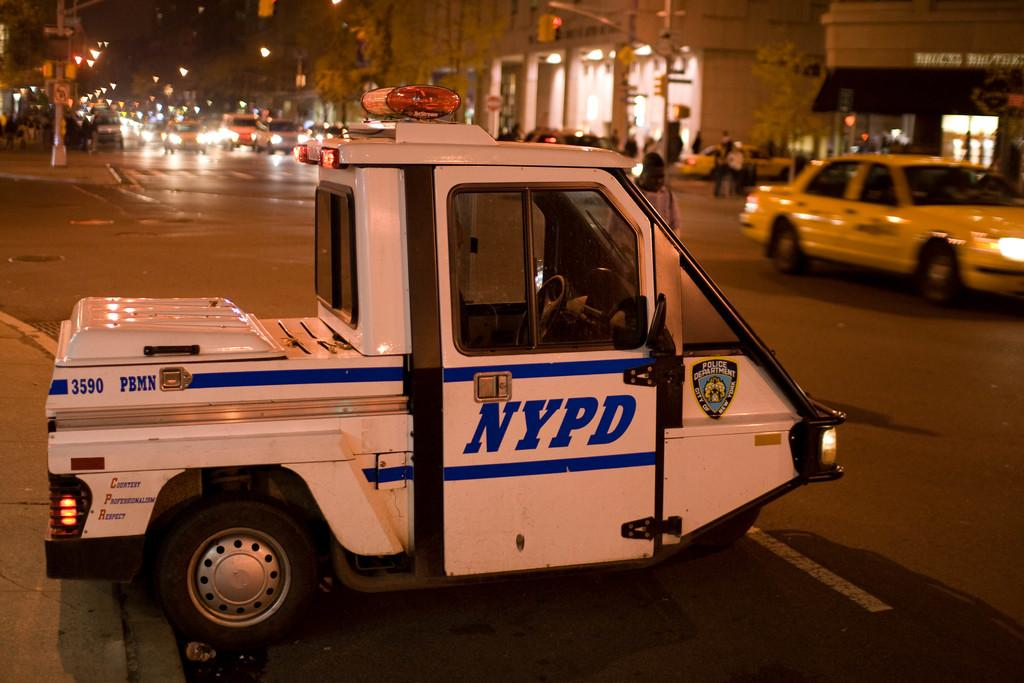<image>
Present a compact description of the photo's key features. A small truck for the NYPD is parked on the side of the street. 